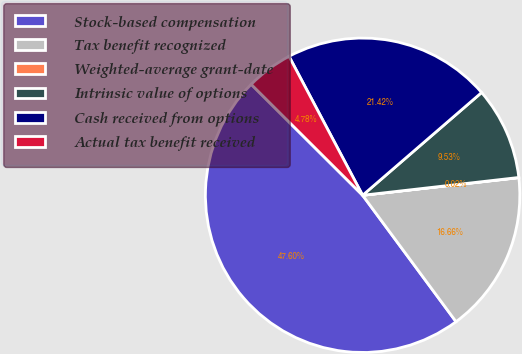Convert chart to OTSL. <chart><loc_0><loc_0><loc_500><loc_500><pie_chart><fcel>Stock-based compensation<fcel>Tax benefit recognized<fcel>Weighted-average grant-date<fcel>Intrinsic value of options<fcel>Cash received from options<fcel>Actual tax benefit received<nl><fcel>47.6%<fcel>16.66%<fcel>0.02%<fcel>9.53%<fcel>21.42%<fcel>4.78%<nl></chart> 